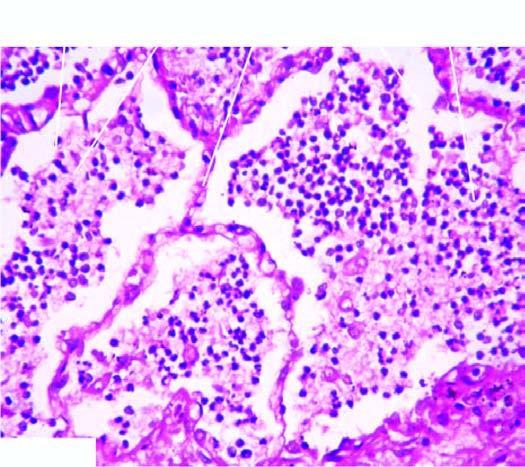what is the infiltrate in the lumina composed of?
Answer the question using a single word or phrase. Ineutrophils and macrophages 